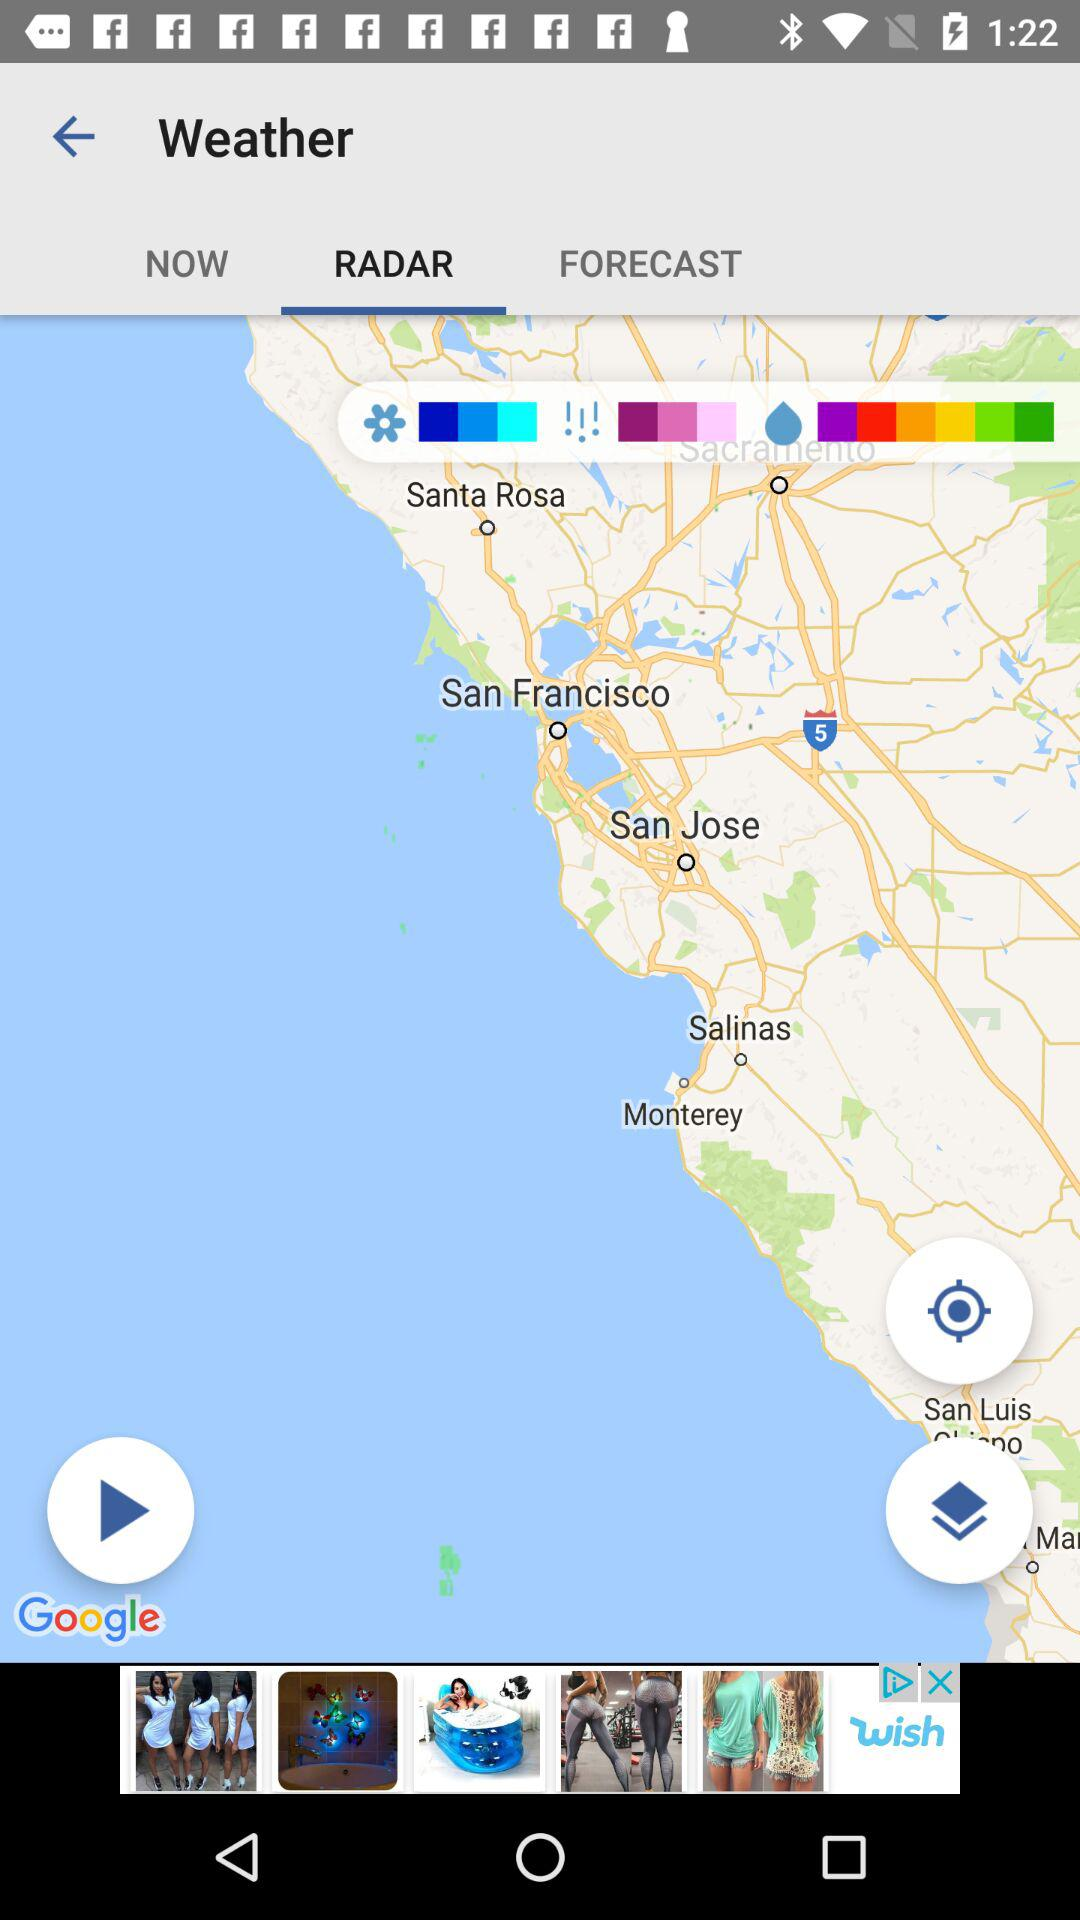Which tab is currently selected? The currently selected tab is "RADAR". 